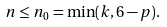Convert formula to latex. <formula><loc_0><loc_0><loc_500><loc_500>n \leq n _ { 0 } = \min ( k , 6 - p ) .</formula> 